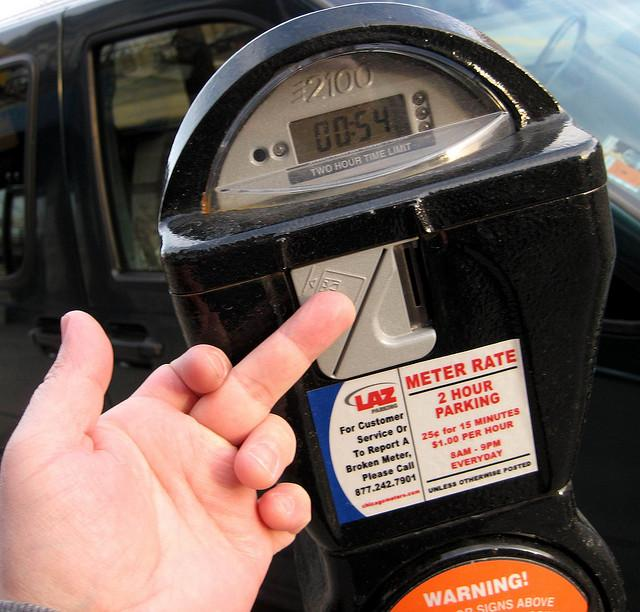What are they doing? Please explain your reasoning. expressing displeasure. The middle finger is a universal hand gesture to express displeasure. 